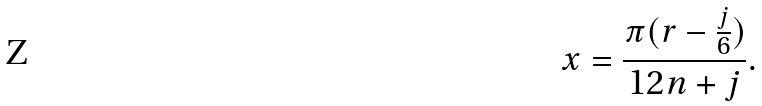Convert formula to latex. <formula><loc_0><loc_0><loc_500><loc_500>x = \frac { \pi ( r - \frac { j } { 6 } ) } { 1 2 n + j } .</formula> 